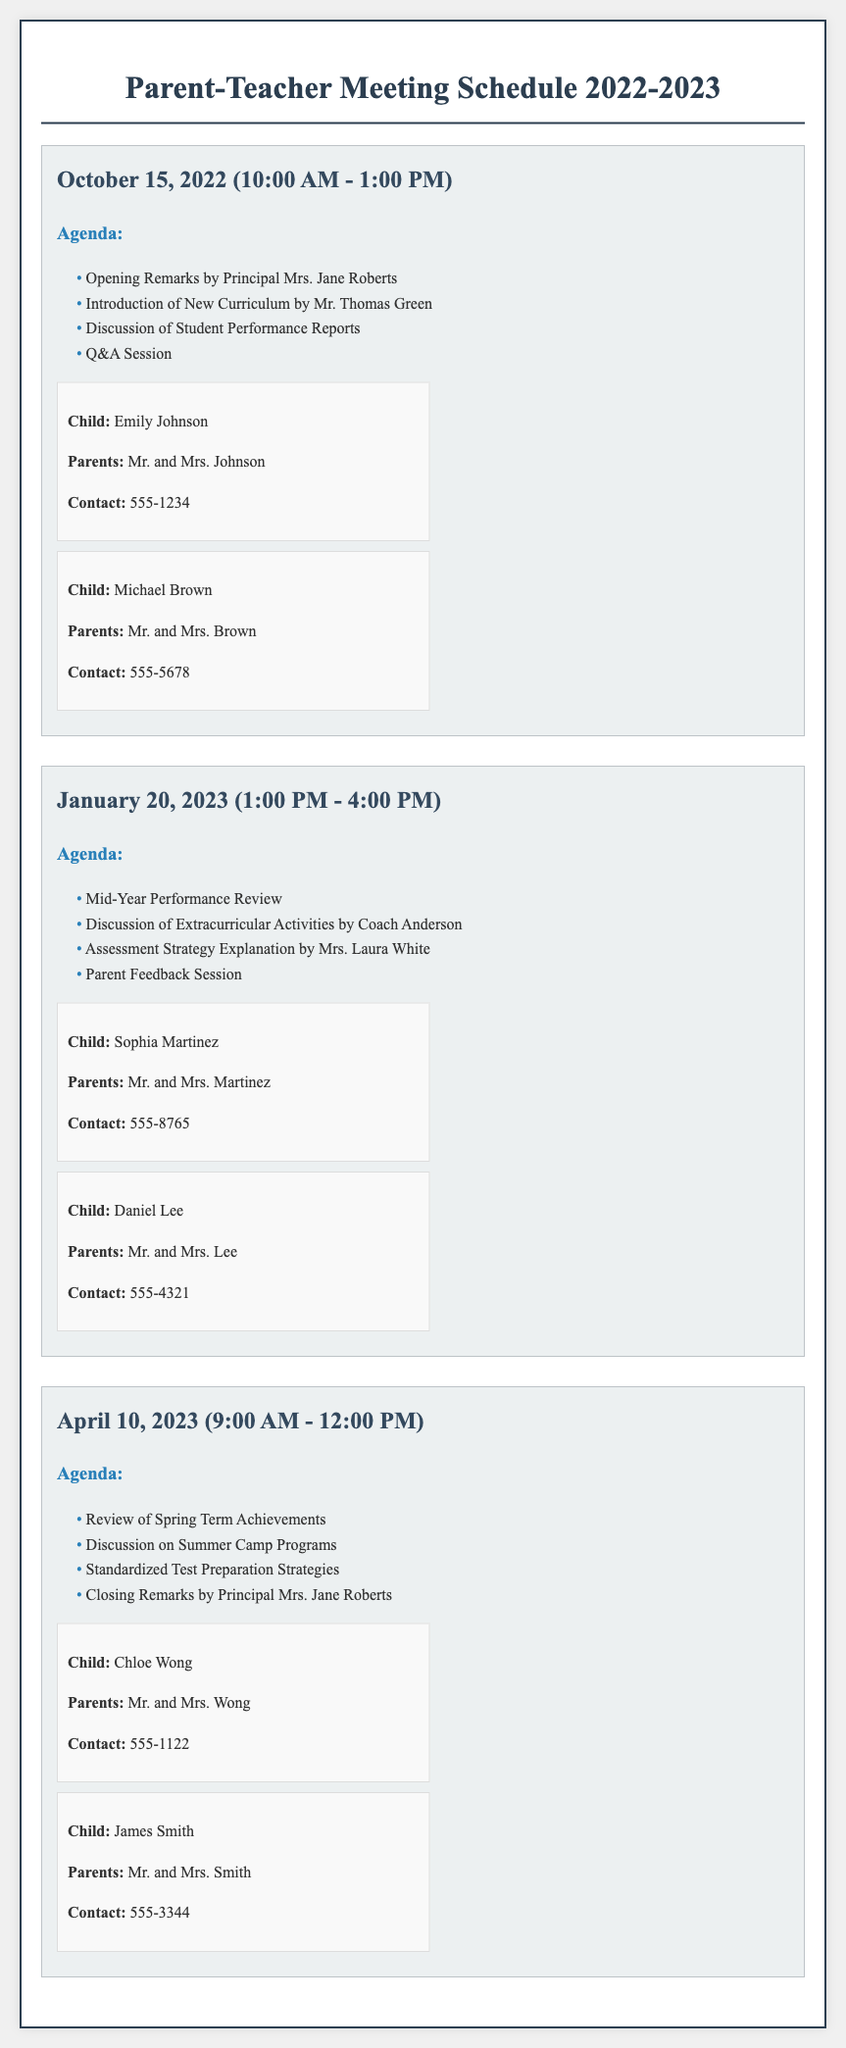What is the date of the first Parent-Teacher Meeting? The first Parent-Teacher Meeting is scheduled for October 15, 2022.
Answer: October 15, 2022 Who will give the opening remarks at the first meeting? The opening remarks will be given by Principal Mrs. Jane Roberts.
Answer: Mrs. Jane Roberts What is the time duration of the meeting on January 20, 2023? The meeting on January 20, 2023, is scheduled from 1:00 PM to 4:00 PM, which is a duration of 3 hours.
Answer: 3 hours How many parents are listed for the April 10, 2023 meeting? There are two sets of parents listed for the meeting on April 10, 2023.
Answer: Two What topic will be discussed regarding extracurricular activities? The discussion of extracurricular activities will be addressed by Coach Anderson.
Answer: Coach Anderson Which child is associated with the contact number 555-5678? The child associated with the contact number 555-5678 is Michael Brown.
Answer: Michael Brown What is one of the agenda items for the April 10, 2023 meeting? One of the agenda items for the April 10, 2023 meeting is the review of Spring Term Achievements.
Answer: Review of Spring Term Achievements What is the final agenda item for the first meeting? The final agenda item for the first meeting is the Q&A Session.
Answer: Q&A Session 